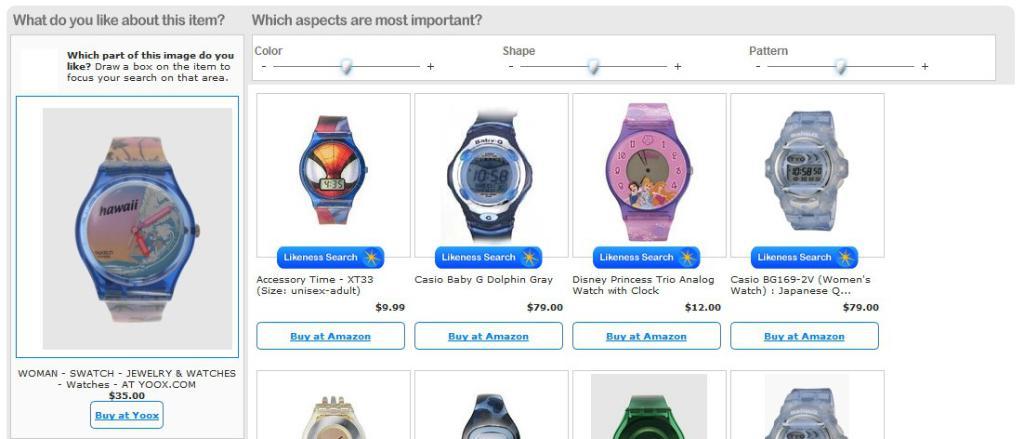Which state is the watch on the left featuring?
Give a very brief answer. Hawaii. How much does the second watch cost?
Offer a terse response. 9.99. 